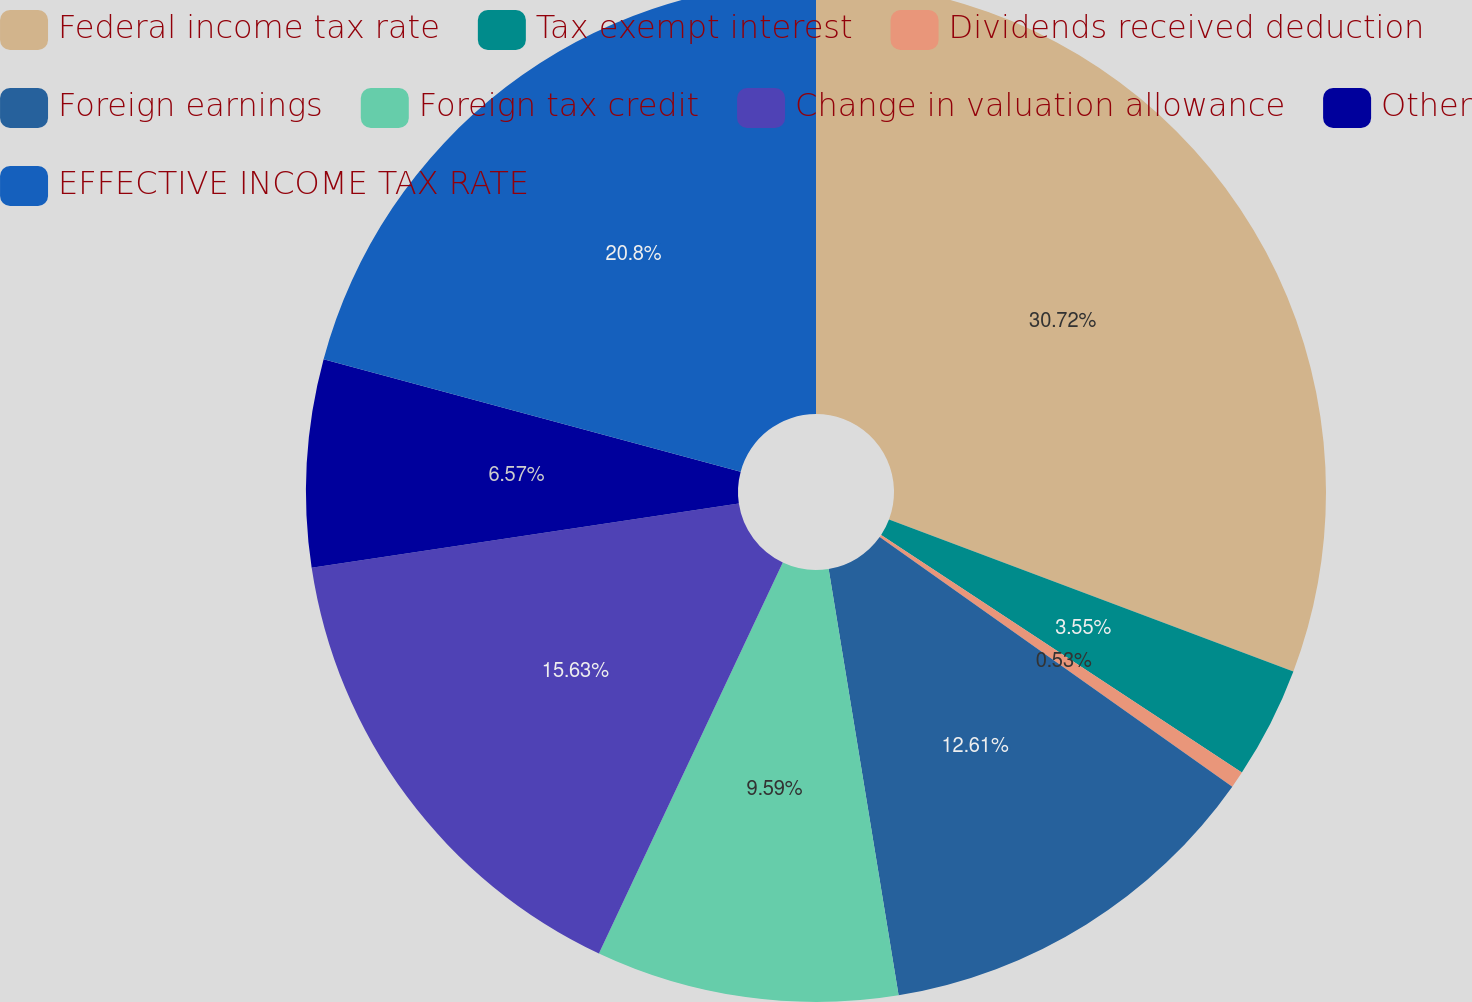Convert chart. <chart><loc_0><loc_0><loc_500><loc_500><pie_chart><fcel>Federal income tax rate<fcel>Tax exempt interest<fcel>Dividends received deduction<fcel>Foreign earnings<fcel>Foreign tax credit<fcel>Change in valuation allowance<fcel>Other<fcel>EFFECTIVE INCOME TAX RATE<nl><fcel>30.73%<fcel>3.55%<fcel>0.53%<fcel>12.61%<fcel>9.59%<fcel>15.63%<fcel>6.57%<fcel>20.81%<nl></chart> 